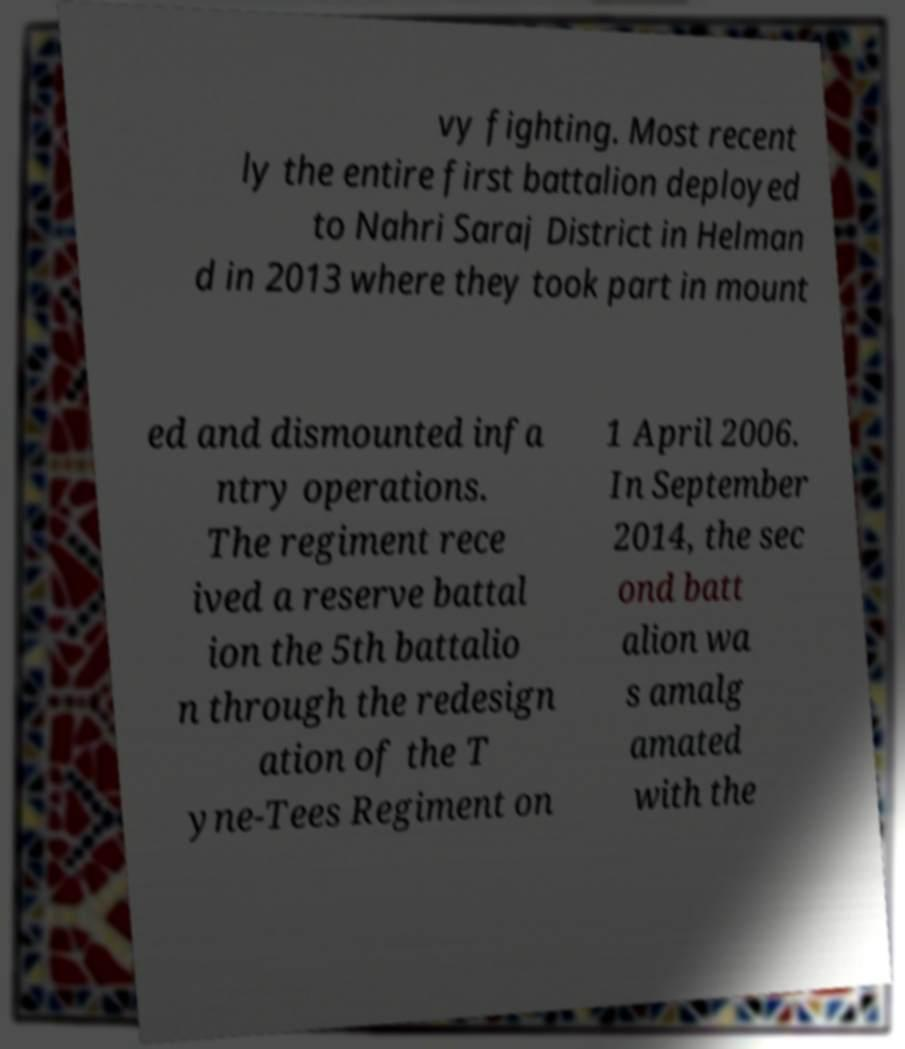Can you read and provide the text displayed in the image?This photo seems to have some interesting text. Can you extract and type it out for me? vy fighting. Most recent ly the entire first battalion deployed to Nahri Saraj District in Helman d in 2013 where they took part in mount ed and dismounted infa ntry operations. The regiment rece ived a reserve battal ion the 5th battalio n through the redesign ation of the T yne-Tees Regiment on 1 April 2006. In September 2014, the sec ond batt alion wa s amalg amated with the 